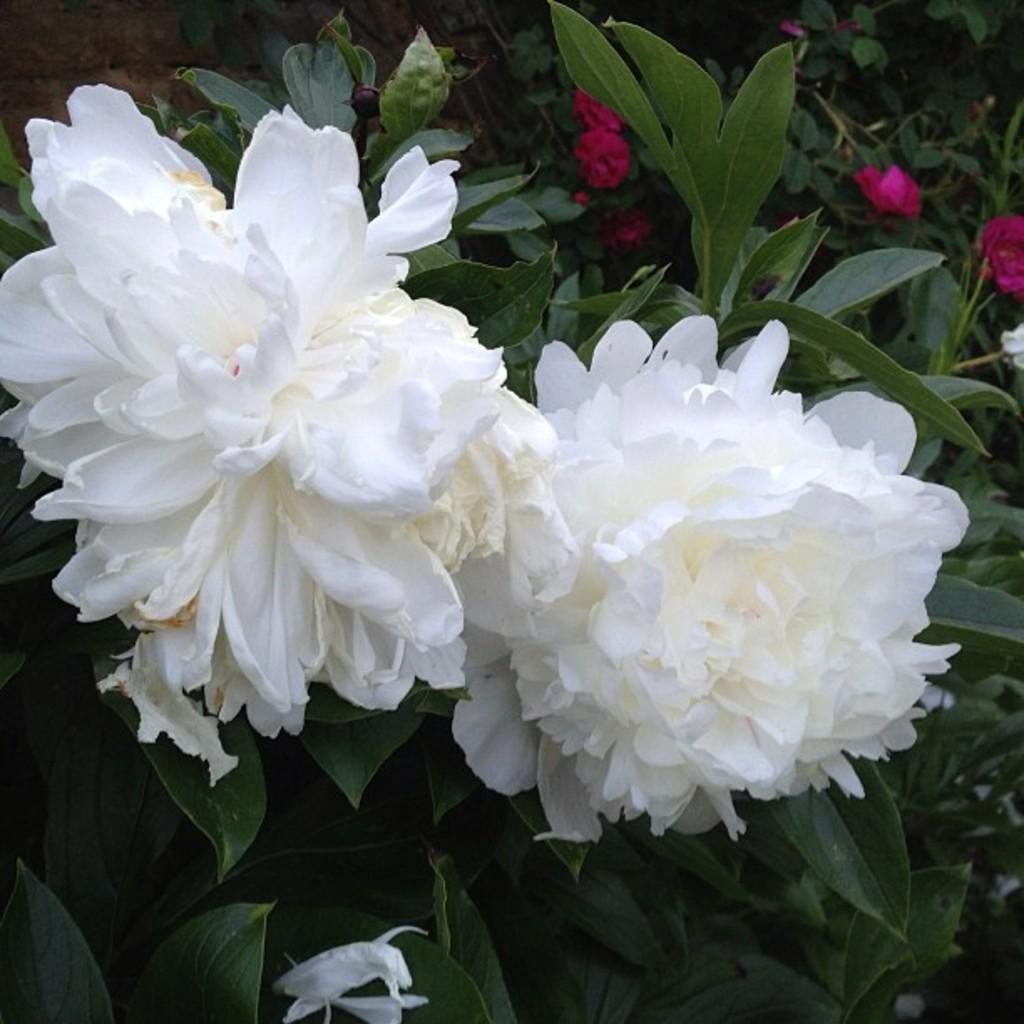What type of living organisms can be seen in the image? Plants can be seen in the image. What distinguishing features can be observed in the plants? The plants have different flowers. What type of club can be seen in the image? There is no club present in the image; it features plants with different flowers. How does the fork interact with the plants in the image? There is no fork present in the image; it only contains plants with different flowers. 